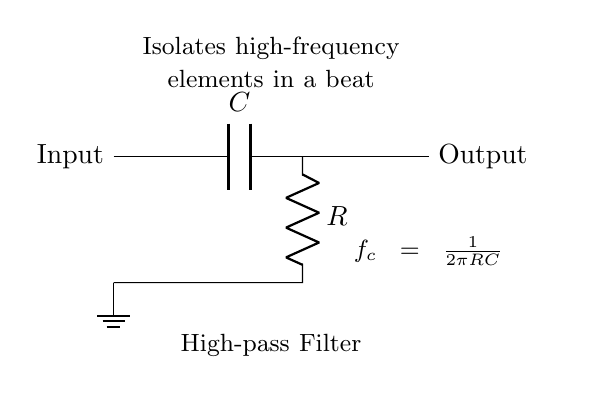What is the type of components used in this circuit? The circuit utilizes a capacitor and a resistor, which are standard components for filters. The diagram clearly labels these components, indicating their specific roles in the circuit as they form the high-pass filter.
Answer: Capacitor and Resistor What is the purpose of this circuit? The circuit is designed to isolate high-frequency elements in a beat, as stated in the diagram. This function is characteristic of high-pass filters, which allow frequencies above a specific cutoff frequency to pass through while attenuating lower frequencies.
Answer: Isolate high-frequency elements What is the formula for the cutoff frequency in this circuit? The cutoff frequency formula is provided at the bottom of the diagram as f_c = 1 / (2πRC). This formula relates the cutoff frequency to the values of the resistor and capacitor used, which determines at what frequency the filter will begin to attenuate lower frequencies.
Answer: f_c = 1 / (2πRC) Which direction does the input signal flow in this circuit? The input signal flows from the left side of the circuit to the right. This can be inferred from the diagram, which shows the input labeled on the left and passes through the capacitor and resistor before reaching the output on the right.
Answer: Left to Right What happens to low-frequency signals in this circuit? Low-frequency signals are attenuated or blocked in a high-pass filter like this one, which means they do not pass through effectively to the output. This behavior is fundamental to the operation of a high-pass filter, as indicated by its purpose in the circuit description.
Answer: Attenuated or blocked What is the role of the capacitor in this circuit? The role of the capacitor is to block low frequencies while allowing high frequencies to pass. In a high-pass filter configuration, the capacitor creates a reactance that decreases with increasing frequency, which is essential for the filtering action.
Answer: Block low frequencies At what frequency does the circuit start to attenuate signals? The start frequency of signal attenuation is defined by the cutoff frequency f_c, which is determined by the values of R and C in the formula provided. Frequencies below this cutoff will be progressively attenuated more than those above it.
Answer: Cutoff frequency f_c 